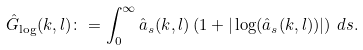Convert formula to latex. <formula><loc_0><loc_0><loc_500><loc_500>\hat { G } _ { \log } ( k , l ) \colon = \int _ { 0 } ^ { \infty } \hat { a } _ { s } ( k , l ) \left ( 1 + | \log ( \hat { a } _ { s } ( k , l ) ) | \right ) \, d s .</formula> 